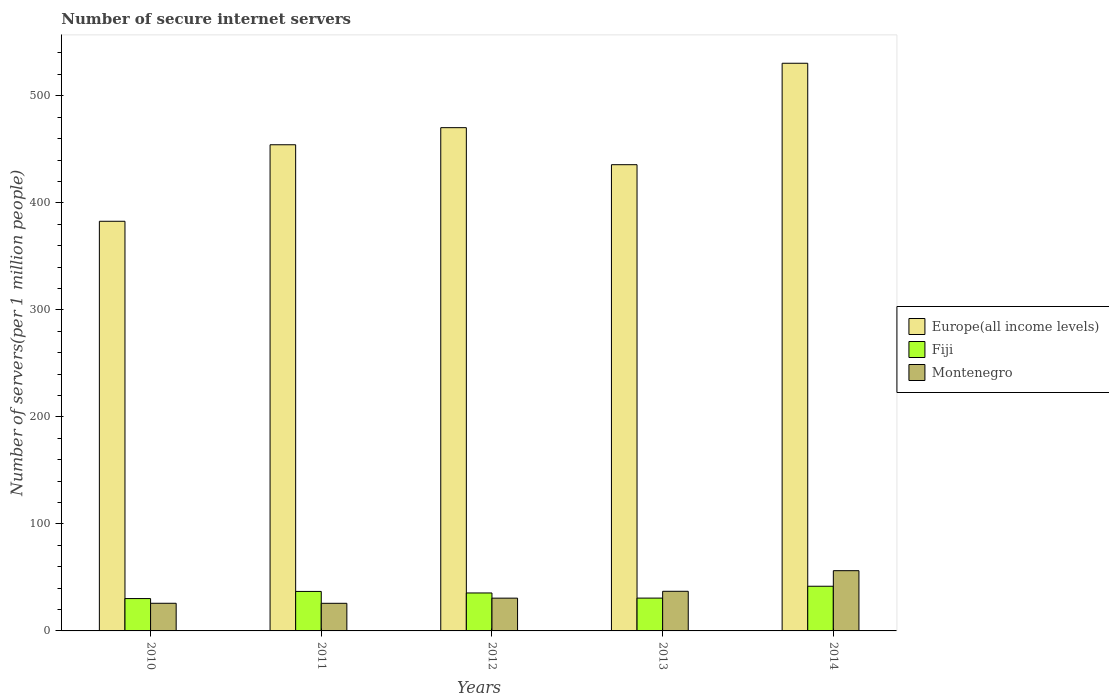Are the number of bars on each tick of the X-axis equal?
Ensure brevity in your answer.  Yes. How many bars are there on the 5th tick from the right?
Provide a short and direct response. 3. What is the label of the 4th group of bars from the left?
Give a very brief answer. 2013. What is the number of secure internet servers in Montenegro in 2011?
Keep it short and to the point. 25.8. Across all years, what is the maximum number of secure internet servers in Montenegro?
Offer a terse response. 56.29. Across all years, what is the minimum number of secure internet servers in Fiji?
Keep it short and to the point. 30.23. In which year was the number of secure internet servers in Fiji maximum?
Provide a short and direct response. 2014. In which year was the number of secure internet servers in Montenegro minimum?
Ensure brevity in your answer.  2011. What is the total number of secure internet servers in Montenegro in the graph?
Your response must be concise. 175.56. What is the difference between the number of secure internet servers in Montenegro in 2010 and that in 2014?
Give a very brief answer. -30.46. What is the difference between the number of secure internet servers in Europe(all income levels) in 2011 and the number of secure internet servers in Montenegro in 2010?
Offer a very short reply. 428.42. What is the average number of secure internet servers in Fiji per year?
Your answer should be compact. 35. In the year 2011, what is the difference between the number of secure internet servers in Montenegro and number of secure internet servers in Europe(all income levels)?
Offer a very short reply. -428.45. What is the ratio of the number of secure internet servers in Montenegro in 2010 to that in 2012?
Your answer should be compact. 0.84. Is the number of secure internet servers in Fiji in 2010 less than that in 2011?
Provide a succinct answer. Yes. What is the difference between the highest and the second highest number of secure internet servers in Montenegro?
Keep it short and to the point. 19.26. What is the difference between the highest and the lowest number of secure internet servers in Montenegro?
Make the answer very short. 30.49. What does the 1st bar from the left in 2011 represents?
Ensure brevity in your answer.  Europe(all income levels). What does the 3rd bar from the right in 2010 represents?
Provide a short and direct response. Europe(all income levels). How many bars are there?
Ensure brevity in your answer.  15. Are the values on the major ticks of Y-axis written in scientific E-notation?
Offer a terse response. No. Does the graph contain grids?
Offer a terse response. No. Where does the legend appear in the graph?
Give a very brief answer. Center right. What is the title of the graph?
Ensure brevity in your answer.  Number of secure internet servers. What is the label or title of the Y-axis?
Offer a terse response. Number of servers(per 1 million people). What is the Number of servers(per 1 million people) in Europe(all income levels) in 2010?
Your answer should be very brief. 382.76. What is the Number of servers(per 1 million people) of Fiji in 2010?
Ensure brevity in your answer.  30.23. What is the Number of servers(per 1 million people) of Montenegro in 2010?
Provide a succinct answer. 25.83. What is the Number of servers(per 1 million people) in Europe(all income levels) in 2011?
Provide a short and direct response. 454.25. What is the Number of servers(per 1 million people) in Fiji in 2011?
Provide a short and direct response. 36.89. What is the Number of servers(per 1 million people) in Montenegro in 2011?
Your answer should be very brief. 25.8. What is the Number of servers(per 1 million people) of Europe(all income levels) in 2012?
Keep it short and to the point. 470.22. What is the Number of servers(per 1 million people) of Fiji in 2012?
Provide a short and direct response. 35.46. What is the Number of servers(per 1 million people) in Montenegro in 2012?
Offer a very short reply. 30.62. What is the Number of servers(per 1 million people) in Europe(all income levels) in 2013?
Make the answer very short. 435.63. What is the Number of servers(per 1 million people) of Fiji in 2013?
Your response must be concise. 30.66. What is the Number of servers(per 1 million people) of Montenegro in 2013?
Keep it short and to the point. 37.02. What is the Number of servers(per 1 million people) of Europe(all income levels) in 2014?
Make the answer very short. 530.4. What is the Number of servers(per 1 million people) of Fiji in 2014?
Your answer should be very brief. 41.74. What is the Number of servers(per 1 million people) of Montenegro in 2014?
Ensure brevity in your answer.  56.29. Across all years, what is the maximum Number of servers(per 1 million people) of Europe(all income levels)?
Keep it short and to the point. 530.4. Across all years, what is the maximum Number of servers(per 1 million people) in Fiji?
Give a very brief answer. 41.74. Across all years, what is the maximum Number of servers(per 1 million people) in Montenegro?
Your response must be concise. 56.29. Across all years, what is the minimum Number of servers(per 1 million people) of Europe(all income levels)?
Offer a terse response. 382.76. Across all years, what is the minimum Number of servers(per 1 million people) in Fiji?
Ensure brevity in your answer.  30.23. Across all years, what is the minimum Number of servers(per 1 million people) in Montenegro?
Give a very brief answer. 25.8. What is the total Number of servers(per 1 million people) of Europe(all income levels) in the graph?
Your answer should be very brief. 2273.27. What is the total Number of servers(per 1 million people) in Fiji in the graph?
Offer a terse response. 175. What is the total Number of servers(per 1 million people) of Montenegro in the graph?
Provide a succinct answer. 175.56. What is the difference between the Number of servers(per 1 million people) of Europe(all income levels) in 2010 and that in 2011?
Ensure brevity in your answer.  -71.5. What is the difference between the Number of servers(per 1 million people) of Fiji in 2010 and that in 2011?
Provide a short and direct response. -6.66. What is the difference between the Number of servers(per 1 million people) in Montenegro in 2010 and that in 2011?
Provide a succinct answer. 0.03. What is the difference between the Number of servers(per 1 million people) in Europe(all income levels) in 2010 and that in 2012?
Give a very brief answer. -87.46. What is the difference between the Number of servers(per 1 million people) of Fiji in 2010 and that in 2012?
Provide a short and direct response. -5.23. What is the difference between the Number of servers(per 1 million people) of Montenegro in 2010 and that in 2012?
Keep it short and to the point. -4.79. What is the difference between the Number of servers(per 1 million people) in Europe(all income levels) in 2010 and that in 2013?
Offer a terse response. -52.87. What is the difference between the Number of servers(per 1 million people) in Fiji in 2010 and that in 2013?
Your answer should be very brief. -0.43. What is the difference between the Number of servers(per 1 million people) in Montenegro in 2010 and that in 2013?
Provide a short and direct response. -11.19. What is the difference between the Number of servers(per 1 million people) of Europe(all income levels) in 2010 and that in 2014?
Offer a very short reply. -147.64. What is the difference between the Number of servers(per 1 million people) of Fiji in 2010 and that in 2014?
Your answer should be very brief. -11.51. What is the difference between the Number of servers(per 1 million people) of Montenegro in 2010 and that in 2014?
Your response must be concise. -30.46. What is the difference between the Number of servers(per 1 million people) of Europe(all income levels) in 2011 and that in 2012?
Your answer should be very brief. -15.97. What is the difference between the Number of servers(per 1 million people) in Fiji in 2011 and that in 2012?
Offer a terse response. 1.43. What is the difference between the Number of servers(per 1 million people) in Montenegro in 2011 and that in 2012?
Keep it short and to the point. -4.81. What is the difference between the Number of servers(per 1 million people) of Europe(all income levels) in 2011 and that in 2013?
Your answer should be compact. 18.63. What is the difference between the Number of servers(per 1 million people) of Fiji in 2011 and that in 2013?
Provide a short and direct response. 6.23. What is the difference between the Number of servers(per 1 million people) in Montenegro in 2011 and that in 2013?
Your response must be concise. -11.22. What is the difference between the Number of servers(per 1 million people) of Europe(all income levels) in 2011 and that in 2014?
Give a very brief answer. -76.15. What is the difference between the Number of servers(per 1 million people) in Fiji in 2011 and that in 2014?
Provide a succinct answer. -4.84. What is the difference between the Number of servers(per 1 million people) in Montenegro in 2011 and that in 2014?
Give a very brief answer. -30.48. What is the difference between the Number of servers(per 1 million people) of Europe(all income levels) in 2012 and that in 2013?
Your response must be concise. 34.6. What is the difference between the Number of servers(per 1 million people) in Fiji in 2012 and that in 2013?
Provide a succinct answer. 4.8. What is the difference between the Number of servers(per 1 million people) in Montenegro in 2012 and that in 2013?
Your answer should be very brief. -6.41. What is the difference between the Number of servers(per 1 million people) of Europe(all income levels) in 2012 and that in 2014?
Your answer should be compact. -60.18. What is the difference between the Number of servers(per 1 million people) of Fiji in 2012 and that in 2014?
Offer a very short reply. -6.28. What is the difference between the Number of servers(per 1 million people) in Montenegro in 2012 and that in 2014?
Keep it short and to the point. -25.67. What is the difference between the Number of servers(per 1 million people) of Europe(all income levels) in 2013 and that in 2014?
Provide a succinct answer. -94.77. What is the difference between the Number of servers(per 1 million people) in Fiji in 2013 and that in 2014?
Make the answer very short. -11.07. What is the difference between the Number of servers(per 1 million people) of Montenegro in 2013 and that in 2014?
Ensure brevity in your answer.  -19.26. What is the difference between the Number of servers(per 1 million people) in Europe(all income levels) in 2010 and the Number of servers(per 1 million people) in Fiji in 2011?
Your answer should be compact. 345.86. What is the difference between the Number of servers(per 1 million people) in Europe(all income levels) in 2010 and the Number of servers(per 1 million people) in Montenegro in 2011?
Provide a short and direct response. 356.96. What is the difference between the Number of servers(per 1 million people) in Fiji in 2010 and the Number of servers(per 1 million people) in Montenegro in 2011?
Offer a terse response. 4.43. What is the difference between the Number of servers(per 1 million people) in Europe(all income levels) in 2010 and the Number of servers(per 1 million people) in Fiji in 2012?
Offer a terse response. 347.3. What is the difference between the Number of servers(per 1 million people) in Europe(all income levels) in 2010 and the Number of servers(per 1 million people) in Montenegro in 2012?
Ensure brevity in your answer.  352.14. What is the difference between the Number of servers(per 1 million people) in Fiji in 2010 and the Number of servers(per 1 million people) in Montenegro in 2012?
Your response must be concise. -0.38. What is the difference between the Number of servers(per 1 million people) of Europe(all income levels) in 2010 and the Number of servers(per 1 million people) of Fiji in 2013?
Offer a terse response. 352.09. What is the difference between the Number of servers(per 1 million people) of Europe(all income levels) in 2010 and the Number of servers(per 1 million people) of Montenegro in 2013?
Offer a terse response. 345.74. What is the difference between the Number of servers(per 1 million people) of Fiji in 2010 and the Number of servers(per 1 million people) of Montenegro in 2013?
Your answer should be very brief. -6.79. What is the difference between the Number of servers(per 1 million people) in Europe(all income levels) in 2010 and the Number of servers(per 1 million people) in Fiji in 2014?
Provide a short and direct response. 341.02. What is the difference between the Number of servers(per 1 million people) in Europe(all income levels) in 2010 and the Number of servers(per 1 million people) in Montenegro in 2014?
Your answer should be compact. 326.47. What is the difference between the Number of servers(per 1 million people) in Fiji in 2010 and the Number of servers(per 1 million people) in Montenegro in 2014?
Offer a terse response. -26.05. What is the difference between the Number of servers(per 1 million people) in Europe(all income levels) in 2011 and the Number of servers(per 1 million people) in Fiji in 2012?
Offer a terse response. 418.79. What is the difference between the Number of servers(per 1 million people) of Europe(all income levels) in 2011 and the Number of servers(per 1 million people) of Montenegro in 2012?
Keep it short and to the point. 423.64. What is the difference between the Number of servers(per 1 million people) of Fiji in 2011 and the Number of servers(per 1 million people) of Montenegro in 2012?
Give a very brief answer. 6.28. What is the difference between the Number of servers(per 1 million people) of Europe(all income levels) in 2011 and the Number of servers(per 1 million people) of Fiji in 2013?
Your answer should be very brief. 423.59. What is the difference between the Number of servers(per 1 million people) in Europe(all income levels) in 2011 and the Number of servers(per 1 million people) in Montenegro in 2013?
Ensure brevity in your answer.  417.23. What is the difference between the Number of servers(per 1 million people) in Fiji in 2011 and the Number of servers(per 1 million people) in Montenegro in 2013?
Your response must be concise. -0.13. What is the difference between the Number of servers(per 1 million people) in Europe(all income levels) in 2011 and the Number of servers(per 1 million people) in Fiji in 2014?
Your response must be concise. 412.52. What is the difference between the Number of servers(per 1 million people) of Europe(all income levels) in 2011 and the Number of servers(per 1 million people) of Montenegro in 2014?
Offer a very short reply. 397.97. What is the difference between the Number of servers(per 1 million people) of Fiji in 2011 and the Number of servers(per 1 million people) of Montenegro in 2014?
Your answer should be very brief. -19.39. What is the difference between the Number of servers(per 1 million people) of Europe(all income levels) in 2012 and the Number of servers(per 1 million people) of Fiji in 2013?
Ensure brevity in your answer.  439.56. What is the difference between the Number of servers(per 1 million people) of Europe(all income levels) in 2012 and the Number of servers(per 1 million people) of Montenegro in 2013?
Offer a very short reply. 433.2. What is the difference between the Number of servers(per 1 million people) of Fiji in 2012 and the Number of servers(per 1 million people) of Montenegro in 2013?
Your answer should be compact. -1.56. What is the difference between the Number of servers(per 1 million people) of Europe(all income levels) in 2012 and the Number of servers(per 1 million people) of Fiji in 2014?
Your answer should be very brief. 428.48. What is the difference between the Number of servers(per 1 million people) in Europe(all income levels) in 2012 and the Number of servers(per 1 million people) in Montenegro in 2014?
Your response must be concise. 413.94. What is the difference between the Number of servers(per 1 million people) in Fiji in 2012 and the Number of servers(per 1 million people) in Montenegro in 2014?
Your answer should be very brief. -20.83. What is the difference between the Number of servers(per 1 million people) in Europe(all income levels) in 2013 and the Number of servers(per 1 million people) in Fiji in 2014?
Offer a very short reply. 393.89. What is the difference between the Number of servers(per 1 million people) in Europe(all income levels) in 2013 and the Number of servers(per 1 million people) in Montenegro in 2014?
Provide a short and direct response. 379.34. What is the difference between the Number of servers(per 1 million people) of Fiji in 2013 and the Number of servers(per 1 million people) of Montenegro in 2014?
Your answer should be very brief. -25.62. What is the average Number of servers(per 1 million people) in Europe(all income levels) per year?
Your response must be concise. 454.65. What is the average Number of servers(per 1 million people) in Fiji per year?
Make the answer very short. 35. What is the average Number of servers(per 1 million people) of Montenegro per year?
Provide a succinct answer. 35.11. In the year 2010, what is the difference between the Number of servers(per 1 million people) of Europe(all income levels) and Number of servers(per 1 million people) of Fiji?
Ensure brevity in your answer.  352.53. In the year 2010, what is the difference between the Number of servers(per 1 million people) of Europe(all income levels) and Number of servers(per 1 million people) of Montenegro?
Provide a short and direct response. 356.93. In the year 2010, what is the difference between the Number of servers(per 1 million people) of Fiji and Number of servers(per 1 million people) of Montenegro?
Keep it short and to the point. 4.4. In the year 2011, what is the difference between the Number of servers(per 1 million people) of Europe(all income levels) and Number of servers(per 1 million people) of Fiji?
Your answer should be compact. 417.36. In the year 2011, what is the difference between the Number of servers(per 1 million people) in Europe(all income levels) and Number of servers(per 1 million people) in Montenegro?
Provide a short and direct response. 428.45. In the year 2011, what is the difference between the Number of servers(per 1 million people) of Fiji and Number of servers(per 1 million people) of Montenegro?
Keep it short and to the point. 11.09. In the year 2012, what is the difference between the Number of servers(per 1 million people) in Europe(all income levels) and Number of servers(per 1 million people) in Fiji?
Keep it short and to the point. 434.76. In the year 2012, what is the difference between the Number of servers(per 1 million people) of Europe(all income levels) and Number of servers(per 1 million people) of Montenegro?
Your response must be concise. 439.61. In the year 2012, what is the difference between the Number of servers(per 1 million people) of Fiji and Number of servers(per 1 million people) of Montenegro?
Offer a terse response. 4.85. In the year 2013, what is the difference between the Number of servers(per 1 million people) in Europe(all income levels) and Number of servers(per 1 million people) in Fiji?
Provide a succinct answer. 404.96. In the year 2013, what is the difference between the Number of servers(per 1 million people) in Europe(all income levels) and Number of servers(per 1 million people) in Montenegro?
Provide a succinct answer. 398.6. In the year 2013, what is the difference between the Number of servers(per 1 million people) of Fiji and Number of servers(per 1 million people) of Montenegro?
Ensure brevity in your answer.  -6.36. In the year 2014, what is the difference between the Number of servers(per 1 million people) in Europe(all income levels) and Number of servers(per 1 million people) in Fiji?
Your response must be concise. 488.66. In the year 2014, what is the difference between the Number of servers(per 1 million people) in Europe(all income levels) and Number of servers(per 1 million people) in Montenegro?
Offer a very short reply. 474.11. In the year 2014, what is the difference between the Number of servers(per 1 million people) in Fiji and Number of servers(per 1 million people) in Montenegro?
Offer a terse response. -14.55. What is the ratio of the Number of servers(per 1 million people) of Europe(all income levels) in 2010 to that in 2011?
Your answer should be very brief. 0.84. What is the ratio of the Number of servers(per 1 million people) of Fiji in 2010 to that in 2011?
Ensure brevity in your answer.  0.82. What is the ratio of the Number of servers(per 1 million people) of Europe(all income levels) in 2010 to that in 2012?
Ensure brevity in your answer.  0.81. What is the ratio of the Number of servers(per 1 million people) in Fiji in 2010 to that in 2012?
Provide a short and direct response. 0.85. What is the ratio of the Number of servers(per 1 million people) in Montenegro in 2010 to that in 2012?
Offer a very short reply. 0.84. What is the ratio of the Number of servers(per 1 million people) of Europe(all income levels) in 2010 to that in 2013?
Offer a terse response. 0.88. What is the ratio of the Number of servers(per 1 million people) in Montenegro in 2010 to that in 2013?
Make the answer very short. 0.7. What is the ratio of the Number of servers(per 1 million people) in Europe(all income levels) in 2010 to that in 2014?
Your answer should be very brief. 0.72. What is the ratio of the Number of servers(per 1 million people) in Fiji in 2010 to that in 2014?
Your answer should be very brief. 0.72. What is the ratio of the Number of servers(per 1 million people) of Montenegro in 2010 to that in 2014?
Keep it short and to the point. 0.46. What is the ratio of the Number of servers(per 1 million people) of Fiji in 2011 to that in 2012?
Keep it short and to the point. 1.04. What is the ratio of the Number of servers(per 1 million people) in Montenegro in 2011 to that in 2012?
Keep it short and to the point. 0.84. What is the ratio of the Number of servers(per 1 million people) of Europe(all income levels) in 2011 to that in 2013?
Your answer should be compact. 1.04. What is the ratio of the Number of servers(per 1 million people) of Fiji in 2011 to that in 2013?
Your response must be concise. 1.2. What is the ratio of the Number of servers(per 1 million people) of Montenegro in 2011 to that in 2013?
Your response must be concise. 0.7. What is the ratio of the Number of servers(per 1 million people) of Europe(all income levels) in 2011 to that in 2014?
Offer a very short reply. 0.86. What is the ratio of the Number of servers(per 1 million people) in Fiji in 2011 to that in 2014?
Your response must be concise. 0.88. What is the ratio of the Number of servers(per 1 million people) of Montenegro in 2011 to that in 2014?
Offer a very short reply. 0.46. What is the ratio of the Number of servers(per 1 million people) in Europe(all income levels) in 2012 to that in 2013?
Offer a terse response. 1.08. What is the ratio of the Number of servers(per 1 million people) of Fiji in 2012 to that in 2013?
Keep it short and to the point. 1.16. What is the ratio of the Number of servers(per 1 million people) of Montenegro in 2012 to that in 2013?
Your response must be concise. 0.83. What is the ratio of the Number of servers(per 1 million people) in Europe(all income levels) in 2012 to that in 2014?
Offer a very short reply. 0.89. What is the ratio of the Number of servers(per 1 million people) of Fiji in 2012 to that in 2014?
Ensure brevity in your answer.  0.85. What is the ratio of the Number of servers(per 1 million people) in Montenegro in 2012 to that in 2014?
Give a very brief answer. 0.54. What is the ratio of the Number of servers(per 1 million people) in Europe(all income levels) in 2013 to that in 2014?
Give a very brief answer. 0.82. What is the ratio of the Number of servers(per 1 million people) of Fiji in 2013 to that in 2014?
Make the answer very short. 0.73. What is the ratio of the Number of servers(per 1 million people) of Montenegro in 2013 to that in 2014?
Your response must be concise. 0.66. What is the difference between the highest and the second highest Number of servers(per 1 million people) of Europe(all income levels)?
Make the answer very short. 60.18. What is the difference between the highest and the second highest Number of servers(per 1 million people) of Fiji?
Offer a very short reply. 4.84. What is the difference between the highest and the second highest Number of servers(per 1 million people) of Montenegro?
Keep it short and to the point. 19.26. What is the difference between the highest and the lowest Number of servers(per 1 million people) of Europe(all income levels)?
Your response must be concise. 147.64. What is the difference between the highest and the lowest Number of servers(per 1 million people) of Fiji?
Offer a terse response. 11.51. What is the difference between the highest and the lowest Number of servers(per 1 million people) in Montenegro?
Provide a short and direct response. 30.48. 